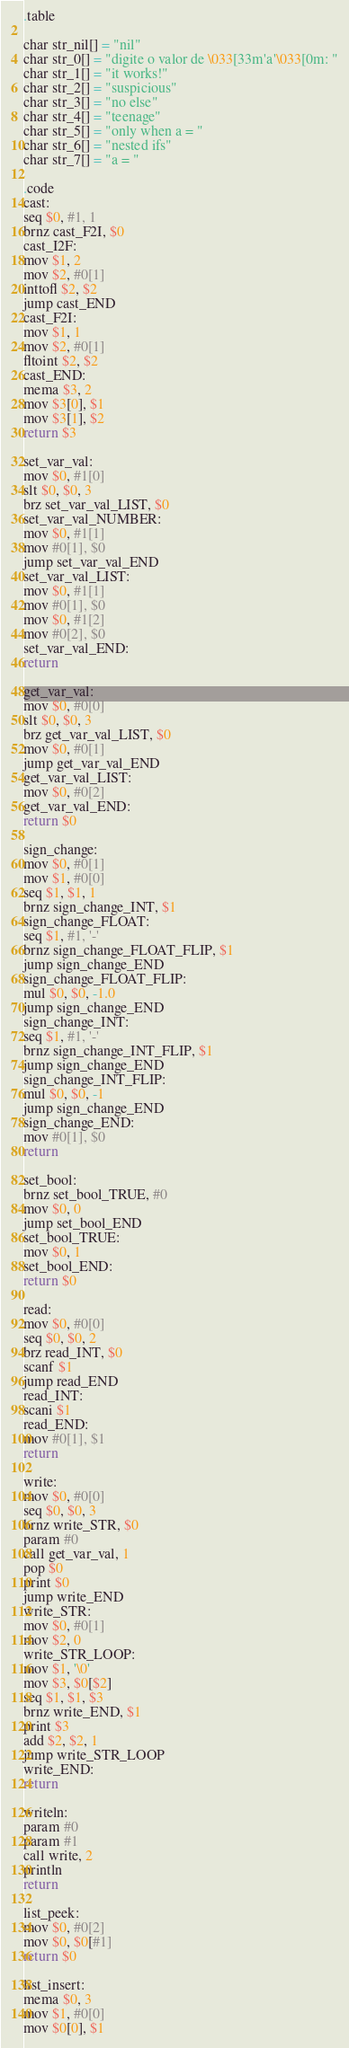<code> <loc_0><loc_0><loc_500><loc_500><_Python_>.table

char str_nil[] = "nil"
char str_0[] = "digite o valor de \033[33m'a'\033[0m: "
char str_1[] = "it works!"
char str_2[] = "suspicious"
char str_3[] = "no else"
char str_4[] = "teenage"
char str_5[] = "only when a = "
char str_6[] = "nested ifs"
char str_7[] = "a = "

.code
cast:
seq $0, #1, 1
brnz cast_F2I, $0
cast_I2F:
mov $1, 2
mov $2, #0[1]
inttofl $2, $2
jump cast_END
cast_F2I:
mov $1, 1
mov $2, #0[1]
fltoint $2, $2
cast_END:
mema $3, 2
mov $3[0], $1
mov $3[1], $2
return $3

set_var_val:
mov $0, #1[0]
slt $0, $0, 3
brz set_var_val_LIST, $0
set_var_val_NUMBER:
mov $0, #1[1]
mov #0[1], $0
jump set_var_val_END
set_var_val_LIST:
mov $0, #1[1]
mov #0[1], $0
mov $0, #1[2]
mov #0[2], $0
set_var_val_END:
return

get_var_val:
mov $0, #0[0]
slt $0, $0, 3
brz get_var_val_LIST, $0
mov $0, #0[1]
jump get_var_val_END
get_var_val_LIST:
mov $0, #0[2]
get_var_val_END:
return $0

sign_change:
mov $0, #0[1]
mov $1, #0[0]
seq $1, $1, 1
brnz sign_change_INT, $1
sign_change_FLOAT:
seq $1, #1, '-'
brnz sign_change_FLOAT_FLIP, $1
jump sign_change_END
sign_change_FLOAT_FLIP:
mul $0, $0, -1.0
jump sign_change_END
sign_change_INT:
seq $1, #1, '-'
brnz sign_change_INT_FLIP, $1
jump sign_change_END
sign_change_INT_FLIP:
mul $0, $0, -1
jump sign_change_END
sign_change_END:
mov #0[1], $0
return

set_bool:
brnz set_bool_TRUE, #0
mov $0, 0
jump set_bool_END
set_bool_TRUE:
mov $0, 1
set_bool_END:
return $0

read:
mov $0, #0[0]
seq $0, $0, 2
brz read_INT, $0
scanf $1
jump read_END
read_INT:
scani $1
read_END:
mov #0[1], $1
return

write:
mov $0, #0[0]
seq $0, $0, 3
brnz write_STR, $0
param #0
call get_var_val, 1
pop $0
print $0
jump write_END
write_STR:
mov $0, #0[1]
mov $2, 0
write_STR_LOOP:
mov $1, '\0'
mov $3, $0[$2]
seq $1, $1, $3
brnz write_END, $1 
print $3
add $2, $2, 1
jump write_STR_LOOP
write_END:
return

writeln:
param #0
param #1
call write, 2
println
return

list_peek:
mov $0, #0[2]
mov $0, $0[#1]
return $0

list_insert:
mema $0, 3
mov $1, #0[0]
mov $0[0], $1</code> 